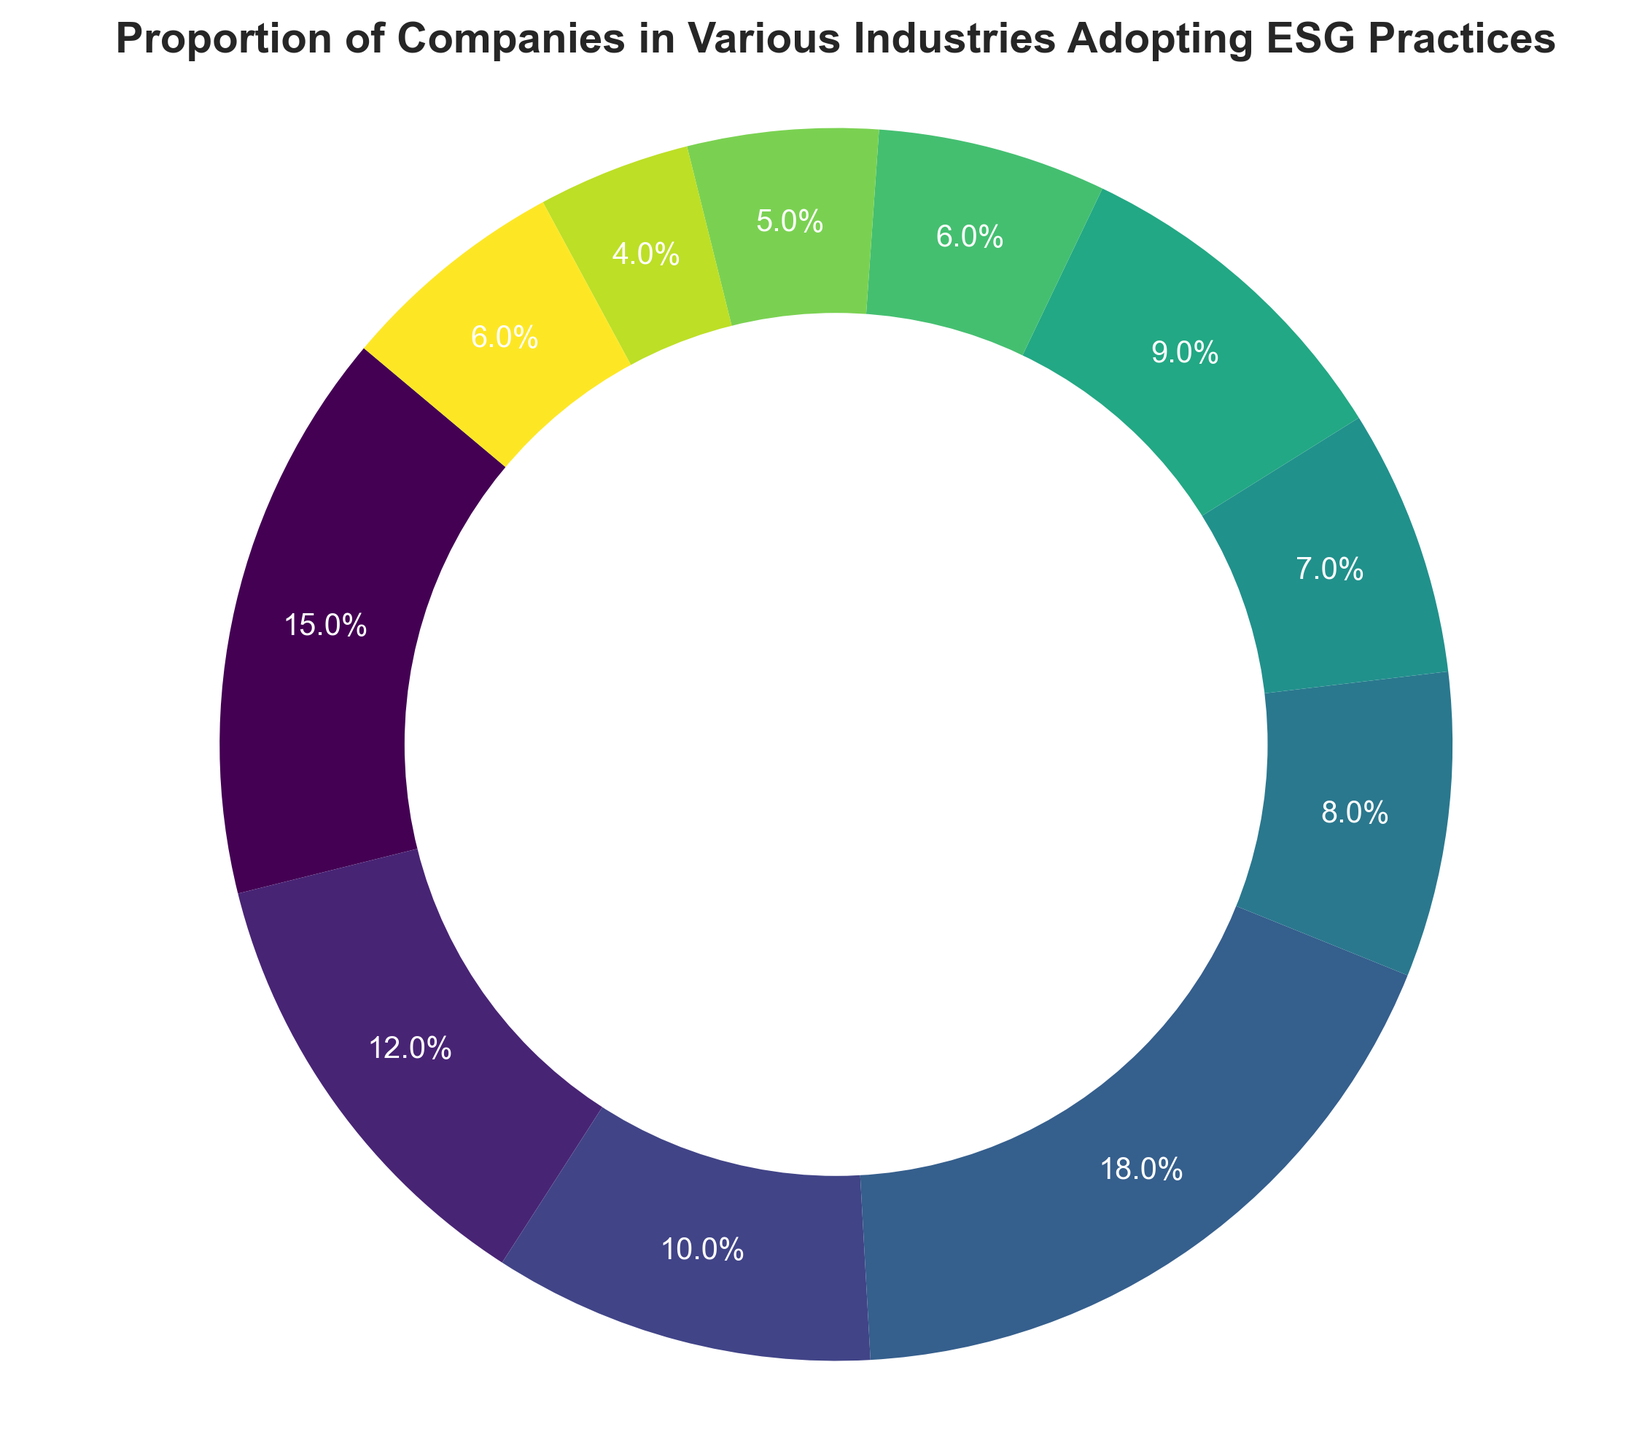Which industry has the highest proportion of companies adopting ESG practices? The pie chart shows that the Consumer Goods industry has the largest slice.
Answer: Consumer Goods Which industry has the lowest proportion of companies adopting ESG practices? The pie chart indicates that the Telecommunications industry has the smallest slice.
Answer: Telecommunications How do the proportions of Technology and Financial Services industries compare in terms of ESG adoption? The pie chart shows that the Technology industry has a 15% proportion while the Financial Services industry has a 12% proportion. Therefore, Technology has a higher proportion than Financial Services.
Answer: Technology has a higher proportion What is the combined proportion of the Healthcare and Industrials industries adopting ESG practices? The Healthcare industry has a 10% proportion and the Industrials industry has a 9% proportion. Adding these gives 10% + 9% = 19%.
Answer: 19% Which two industries together roughly make up one-quarter of the total proportion of companies adopting ESG practices? The Consumer Goods industry is 18% and the Energy industry is 8%; combined they make 18% + 8% = 26%, which is roughly one-quarter.
Answer: Consumer Goods and Energy What is the difference in proportion between the Consumer Goods and Real Estate industries? The Consumer Goods industry has an 18% proportion, and the Real Estate industry has a 5% proportion. The difference is 18% - 5% = 13%.
Answer: 13% Which industry has a larger proportion of ESG adoption, Utilities or Consumer Services? The pie chart shows that the Utilities industry has a 7% proportion while the Consumer Services industry has a 6% proportion. Thus, Utilities has a larger proportion.
Answer: Utilities What proportion of companies in the Energy industry are adopting ESG practices? The pie chart shows that the Energy industry has an 8% proportion.
Answer: 8% What is the combined proportion of companies in the Telecommunications and Materials industries adopting ESG practices? The Telecommunications industry has a 4% proportion and the Materials industry has a 6% proportion. Adding these gives 4% + 6% = 10%.
Answer: 10% If you combine the proportions of the top three industries adopting ESG practices, what is the total proportion? The top three industries by proportion are Consumer Goods (18%), Technology (15%), and Financial Services (12%). Adding these gives 18% + 15% + 12% = 45%.
Answer: 45% 